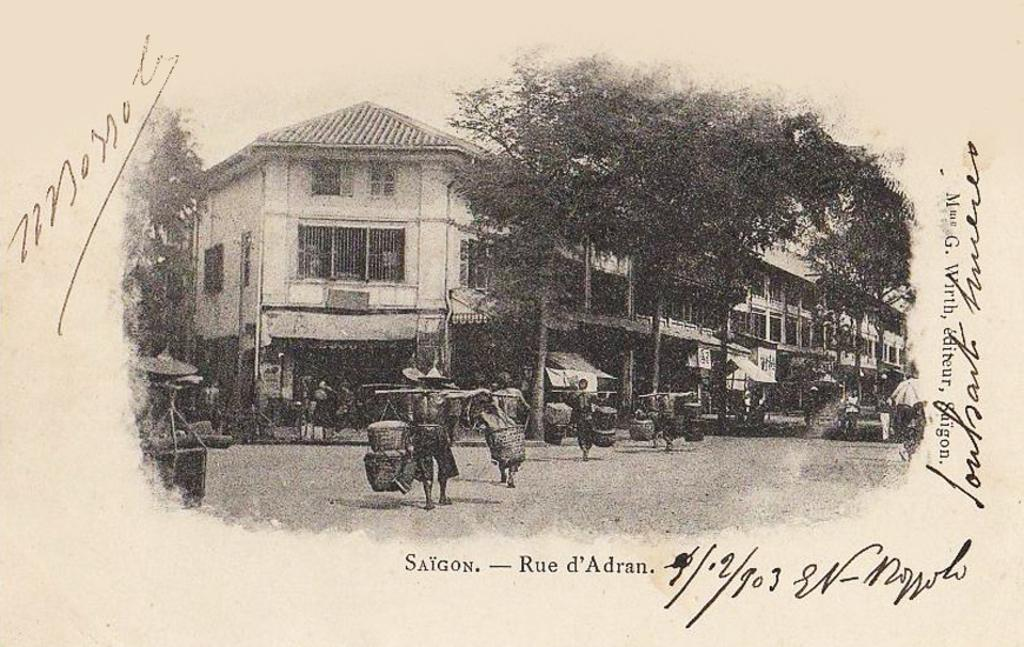What is depicted on the paper in the image? The image contains a picture on a paper. What elements are included in the picture? The picture contains persons, trees, and buildings. Where can text be found in the image? There is text at the bottom of the image and on the right side of the image. What type of cord is used to hang the form in the image? There is no form or cord present in the image; it contains a picture on a paper with text and various elements. 